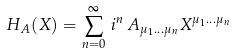Convert formula to latex. <formula><loc_0><loc_0><loc_500><loc_500>H _ { A } ( { X } ) = \sum ^ { \infty } _ { n = 0 } \, i ^ { n } \, A _ { \mu _ { 1 } \dots \mu _ { n } } X ^ { \mu _ { 1 } \dots \mu _ { n } }</formula> 